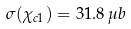Convert formula to latex. <formula><loc_0><loc_0><loc_500><loc_500>\sigma ( \chi _ { c 1 } ) = 3 1 . 8 \, \mu b</formula> 